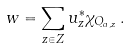<formula> <loc_0><loc_0><loc_500><loc_500>w = \sum _ { z \in Z } u ^ { * } _ { z } \chi _ { Q _ { a , z } } \, .</formula> 